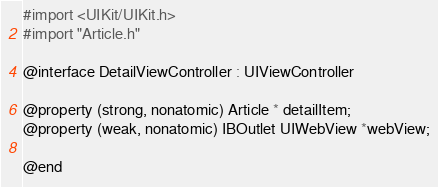Convert code to text. <code><loc_0><loc_0><loc_500><loc_500><_C_>#import <UIKit/UIKit.h>
#import "Article.h"

@interface DetailViewController : UIViewController

@property (strong, nonatomic) Article * detailItem;
@property (weak, nonatomic) IBOutlet UIWebView *webView;

@end
</code> 